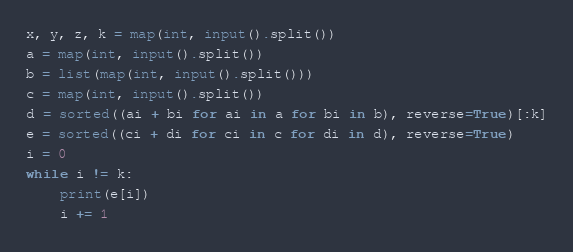Convert code to text. <code><loc_0><loc_0><loc_500><loc_500><_Python_>x, y, z, k = map(int, input().split())
a = map(int, input().split())
b = list(map(int, input().split()))
c = map(int, input().split())
d = sorted((ai + bi for ai in a for bi in b), reverse=True)[:k]
e = sorted((ci + di for ci in c for di in d), reverse=True)
i = 0
while i != k:
    print(e[i])
    i += 1
</code> 